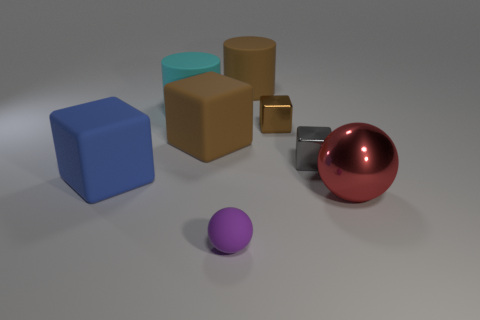Subtract all small gray metallic blocks. How many blocks are left? 3 Add 1 large blue things. How many objects exist? 9 Subtract all brown cylinders. How many brown blocks are left? 2 Subtract all brown cylinders. How many cylinders are left? 1 Add 8 blue cubes. How many blue cubes are left? 9 Add 4 large blue metal blocks. How many large blue metal blocks exist? 4 Subtract 0 gray balls. How many objects are left? 8 Subtract all balls. How many objects are left? 6 Subtract 2 cylinders. How many cylinders are left? 0 Subtract all gray cubes. Subtract all brown cylinders. How many cubes are left? 3 